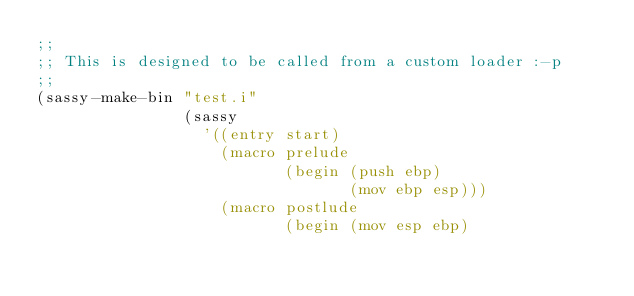Convert code to text. <code><loc_0><loc_0><loc_500><loc_500><_Scheme_>;;
;; This is designed to be called from a custom loader :-p
;;
(sassy-make-bin "test.i"
                (sassy
                  '((entry start)
                    (macro prelude
                           (begin (push ebp)
                                  (mov ebp esp)))
                    (macro postlude
                           (begin (mov esp ebp)</code> 